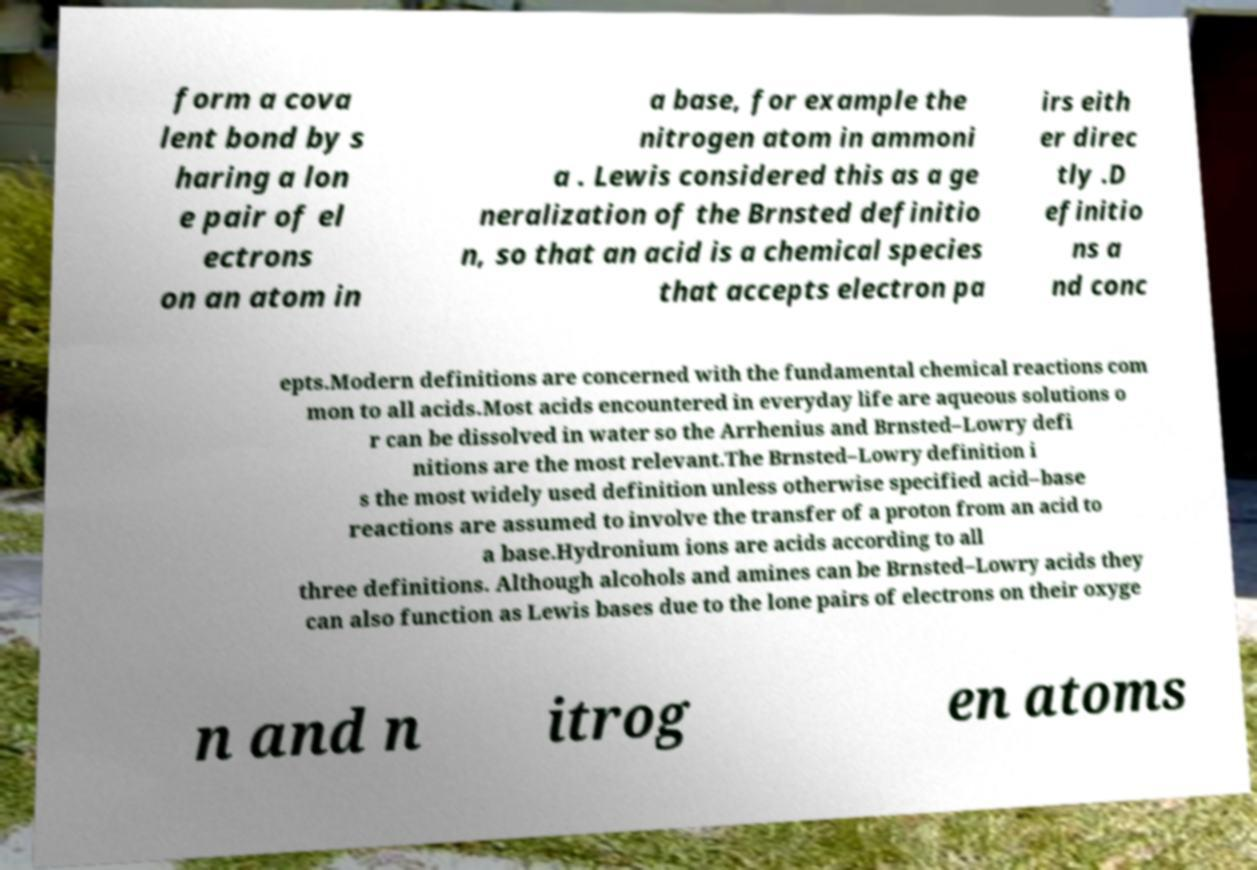Can you accurately transcribe the text from the provided image for me? form a cova lent bond by s haring a lon e pair of el ectrons on an atom in a base, for example the nitrogen atom in ammoni a . Lewis considered this as a ge neralization of the Brnsted definitio n, so that an acid is a chemical species that accepts electron pa irs eith er direc tly .D efinitio ns a nd conc epts.Modern definitions are concerned with the fundamental chemical reactions com mon to all acids.Most acids encountered in everyday life are aqueous solutions o r can be dissolved in water so the Arrhenius and Brnsted–Lowry defi nitions are the most relevant.The Brnsted–Lowry definition i s the most widely used definition unless otherwise specified acid–base reactions are assumed to involve the transfer of a proton from an acid to a base.Hydronium ions are acids according to all three definitions. Although alcohols and amines can be Brnsted–Lowry acids they can also function as Lewis bases due to the lone pairs of electrons on their oxyge n and n itrog en atoms 